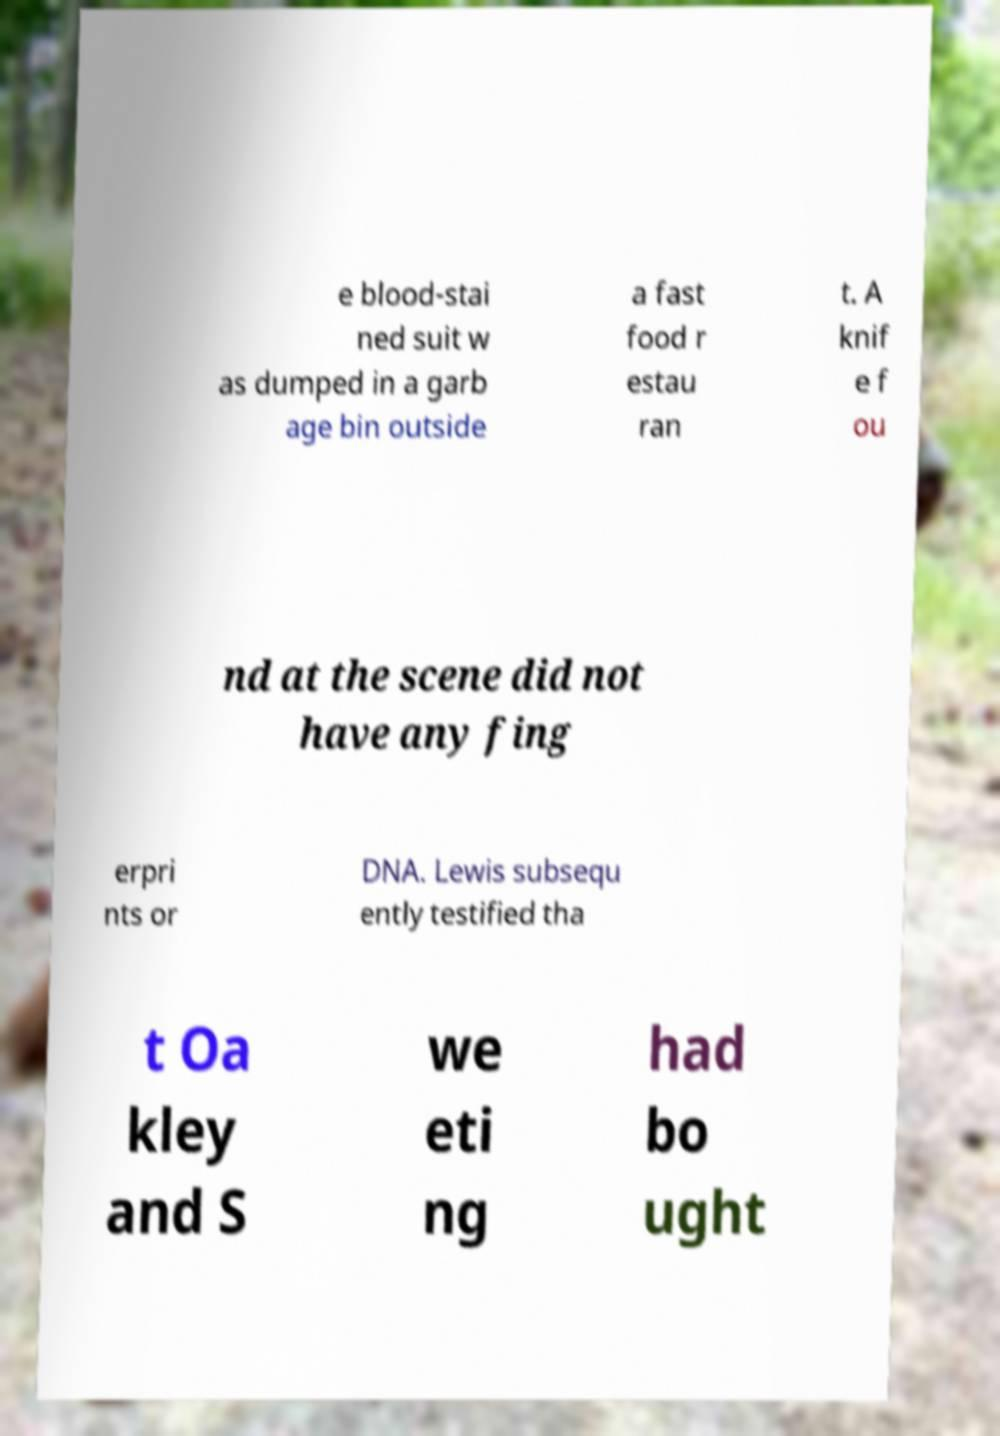I need the written content from this picture converted into text. Can you do that? e blood-stai ned suit w as dumped in a garb age bin outside a fast food r estau ran t. A knif e f ou nd at the scene did not have any fing erpri nts or DNA. Lewis subsequ ently testified tha t Oa kley and S we eti ng had bo ught 